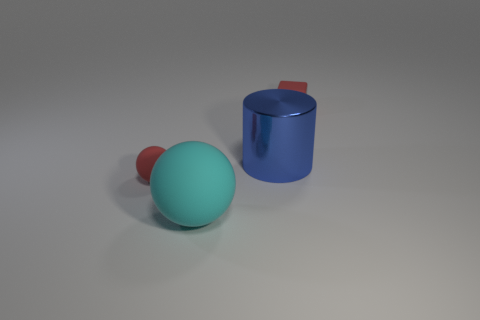Is the size of the cyan ball the same as the block?
Offer a terse response. No. How many other things are there of the same color as the cube?
Your response must be concise. 1. What material is the other thing that is the same size as the cyan thing?
Give a very brief answer. Metal. Are there any other red rubber things of the same shape as the large matte object?
Your answer should be compact. Yes. What shape is the rubber object that is the same size as the red rubber cube?
Provide a short and direct response. Sphere. What number of other big cylinders are the same color as the cylinder?
Your answer should be very brief. 0. There is a red matte object that is on the right side of the large blue shiny cylinder; how big is it?
Provide a succinct answer. Small. What number of matte balls have the same size as the cylinder?
Your answer should be compact. 1. There is a cube that is made of the same material as the cyan object; what is its color?
Offer a terse response. Red. Are there fewer big metallic things behind the large blue thing than big blue objects?
Your answer should be compact. Yes. 